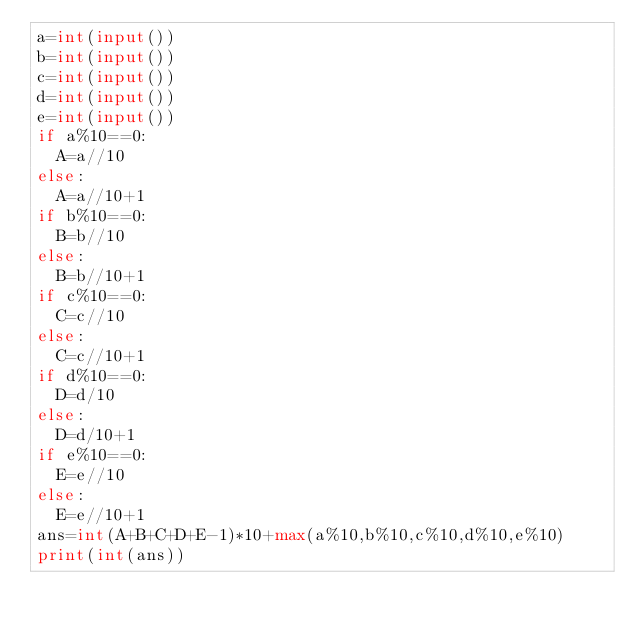Convert code to text. <code><loc_0><loc_0><loc_500><loc_500><_Python_>a=int(input())
b=int(input())
c=int(input())
d=int(input())
e=int(input())
if a%10==0:
  A=a//10
else:
  A=a//10+1
if b%10==0:
  B=b//10
else:
  B=b//10+1
if c%10==0:
  C=c//10
else:
  C=c//10+1
if d%10==0:
  D=d/10
else:
  D=d/10+1
if e%10==0:
  E=e//10
else:
  E=e//10+1
ans=int(A+B+C+D+E-1)*10+max(a%10,b%10,c%10,d%10,e%10)
print(int(ans))</code> 